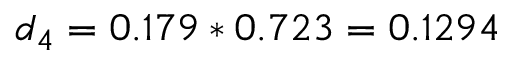<formula> <loc_0><loc_0><loc_500><loc_500>d _ { 4 } = 0 . 1 7 9 * 0 . 7 2 3 = 0 . 1 2 9 4</formula> 